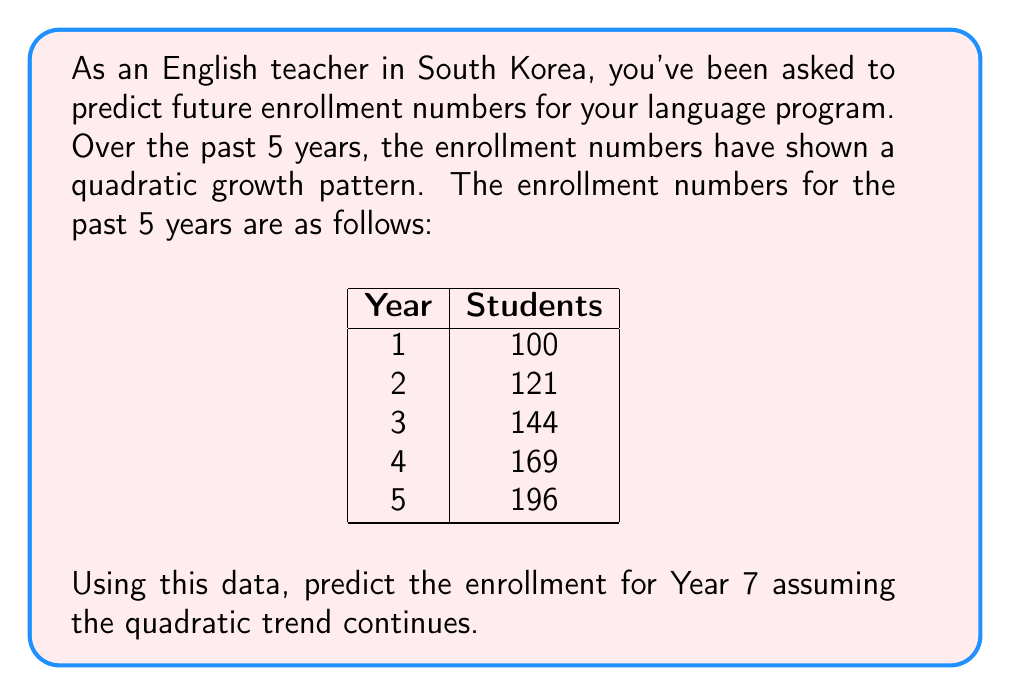Help me with this question. To solve this problem, we need to follow these steps:

1. Recognize the pattern: The given data follows a quadratic growth pattern.

2. Find the quadratic function: We need to find a function in the form $f(x) = ax^2 + bx + c$ where $x$ is the year number (1, 2, 3, ...) and $f(x)$ is the enrollment.

3. Observe that the enrollment numbers are perfect squares: 100 = 10^2, 121 = 11^2, 144 = 12^2, 169 = 13^2, 196 = 14^2.

4. The pattern suggests that the enrollment for year $x$ is $(9+x)^2$.

5. Expand this expression:
   $f(x) = (9+x)^2 = 81 + 18x + x^2$

6. Therefore, our quadratic function is $f(x) = x^2 + 18x + 81$

7. To predict Year 7 enrollment, we substitute $x = 7$ into our function:

   $f(7) = 7^2 + 18(7) + 81$
         $= 49 + 126 + 81$
         $= 256$

Thus, the predicted enrollment for Year 7 is 256 students.
Answer: 256 students 